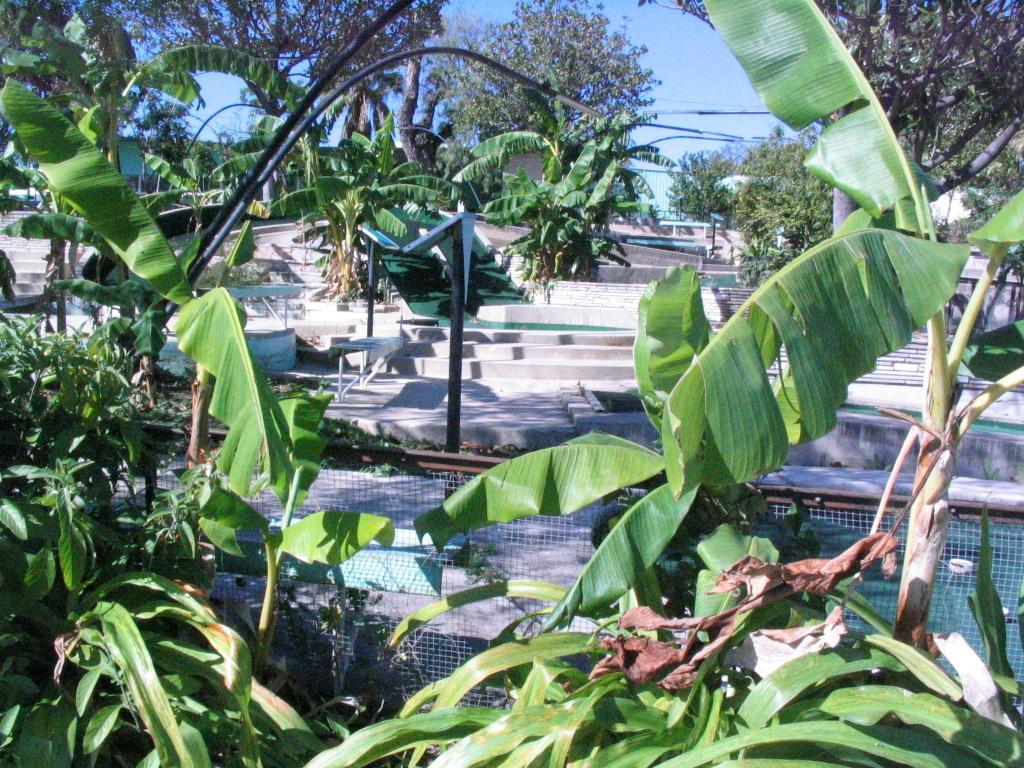Describe this image in one or two sentences. In the image I can see a place where we have some trees, plants, poles, fencing and some other things around. 